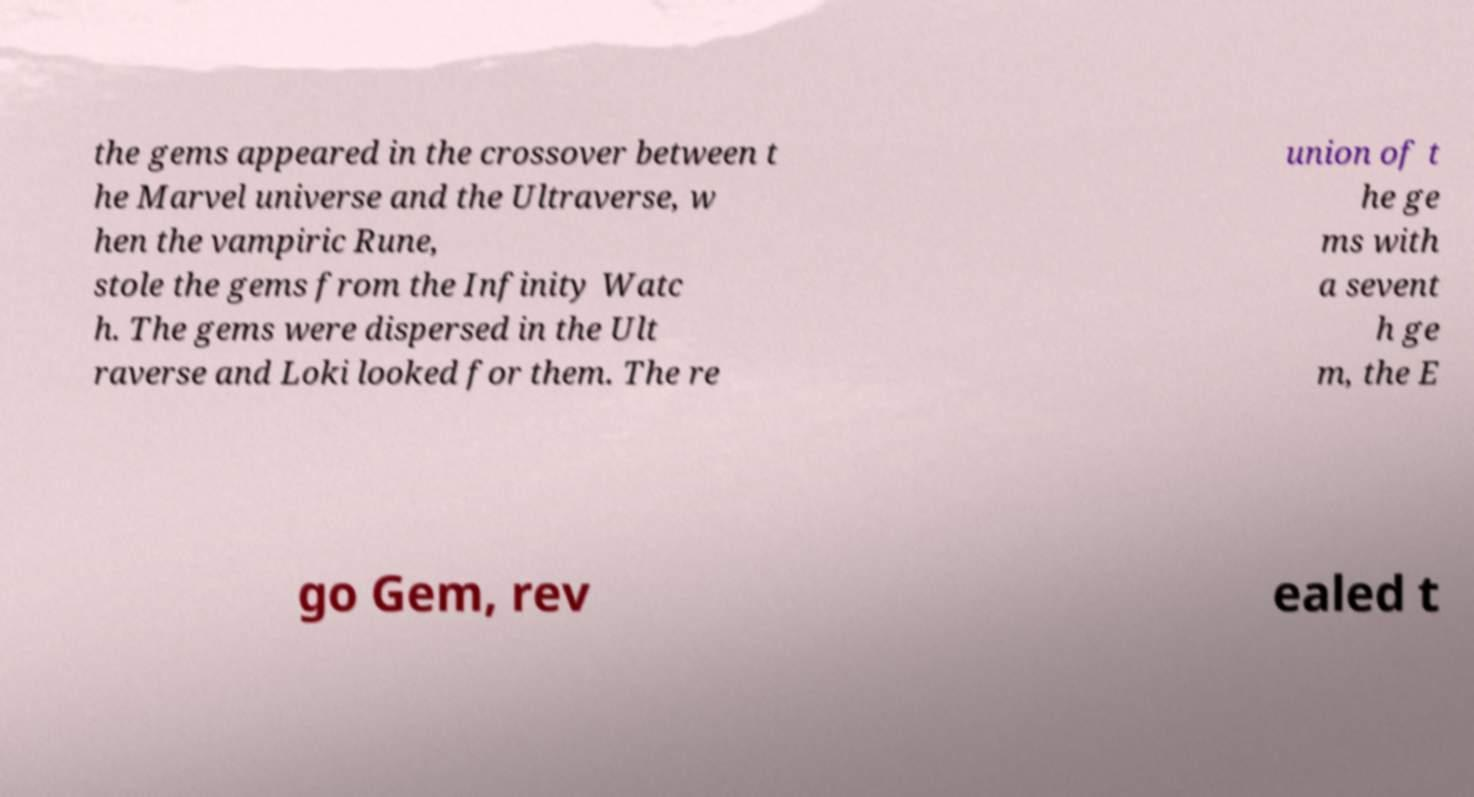Could you extract and type out the text from this image? the gems appeared in the crossover between t he Marvel universe and the Ultraverse, w hen the vampiric Rune, stole the gems from the Infinity Watc h. The gems were dispersed in the Ult raverse and Loki looked for them. The re union of t he ge ms with a sevent h ge m, the E go Gem, rev ealed t 